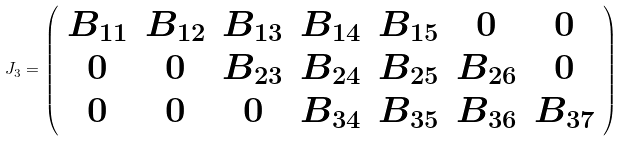Convert formula to latex. <formula><loc_0><loc_0><loc_500><loc_500>J _ { 3 } = \left ( \begin{array} { c c c c c c c } B _ { 1 1 } & B _ { 1 2 } & B _ { 1 3 } & B _ { 1 4 } & B _ { 1 5 } & 0 & 0 \\ 0 & 0 & B _ { 2 3 } & B _ { 2 4 } & B _ { 2 5 } & B _ { 2 6 } & 0 \\ 0 & 0 & 0 & B _ { 3 4 } & B _ { 3 5 } & B _ { 3 6 } & B _ { 3 7 } \end{array} \right )</formula> 